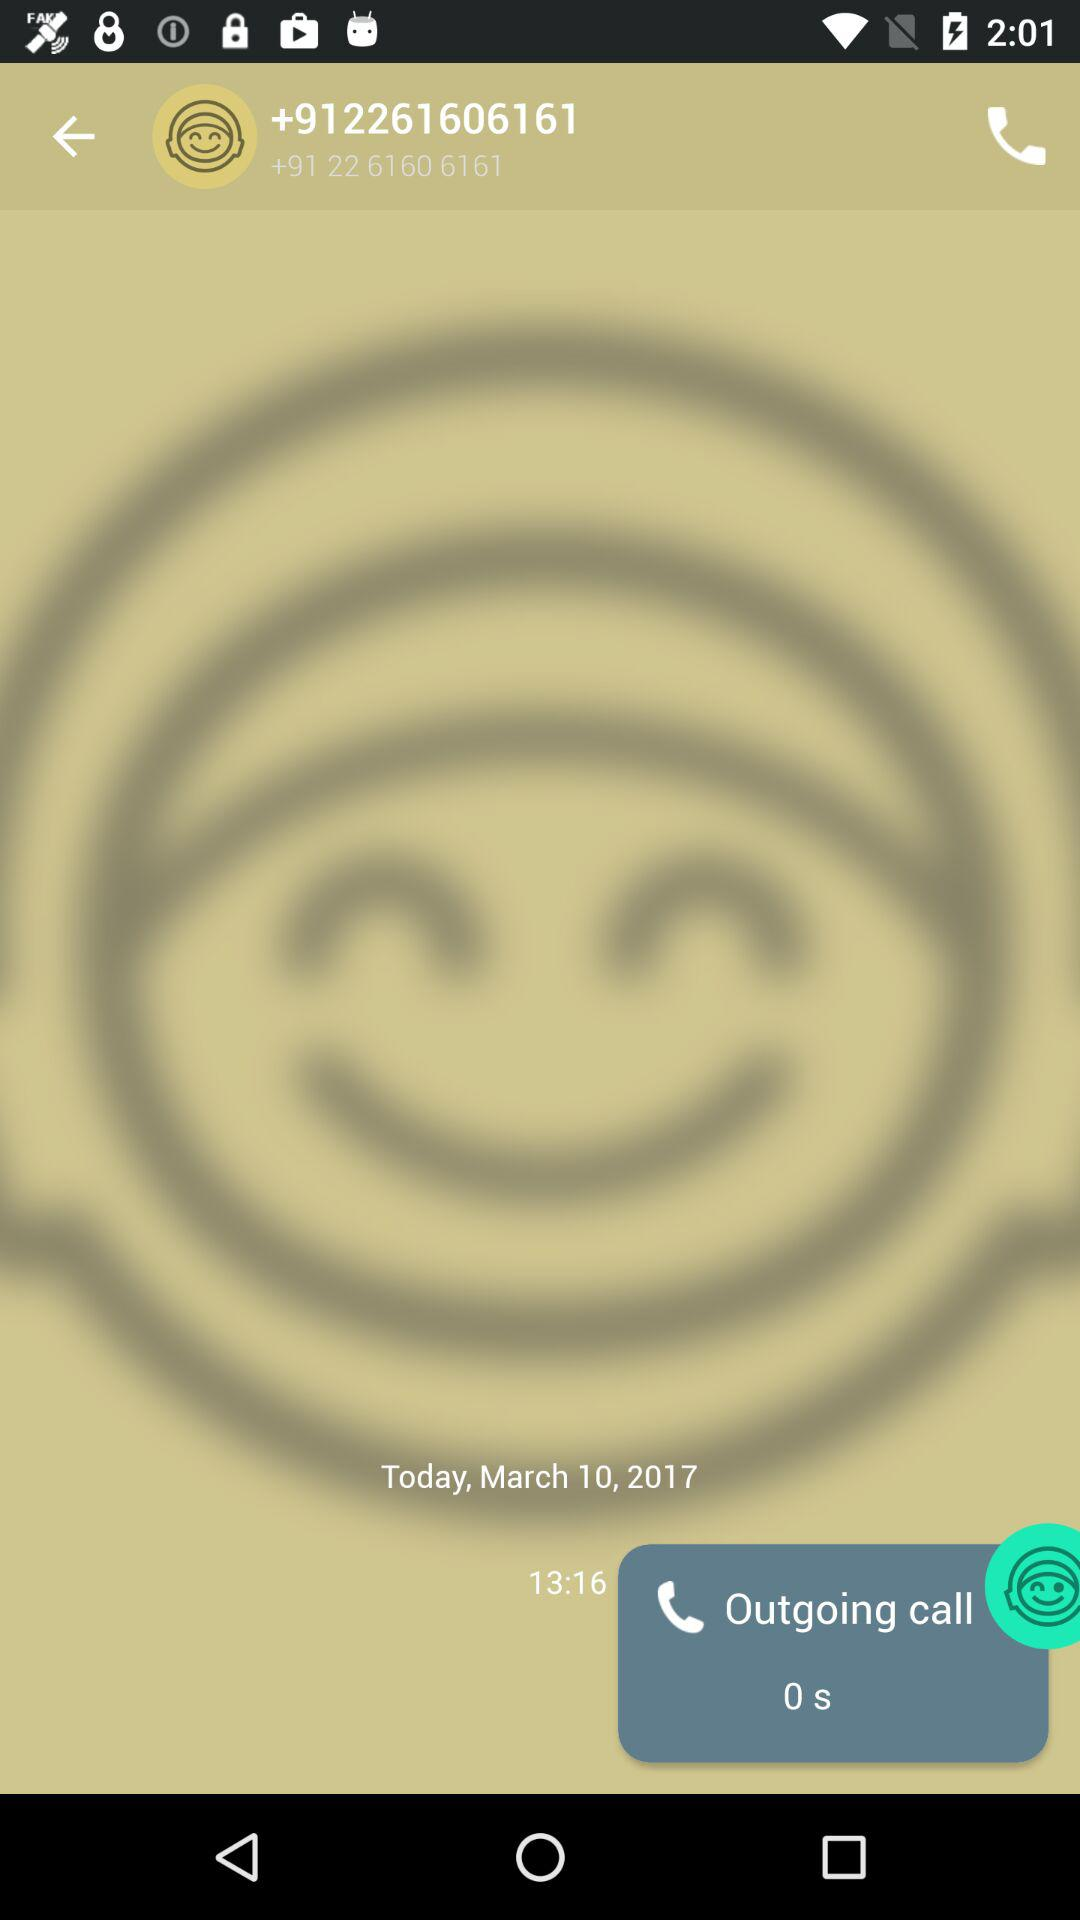What is the duration of the outgoing call? The duration is 0 seconds. 